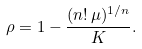<formula> <loc_0><loc_0><loc_500><loc_500>\rho = 1 - \frac { ( n ! \, \mu ) ^ { 1 / n } } K .</formula> 